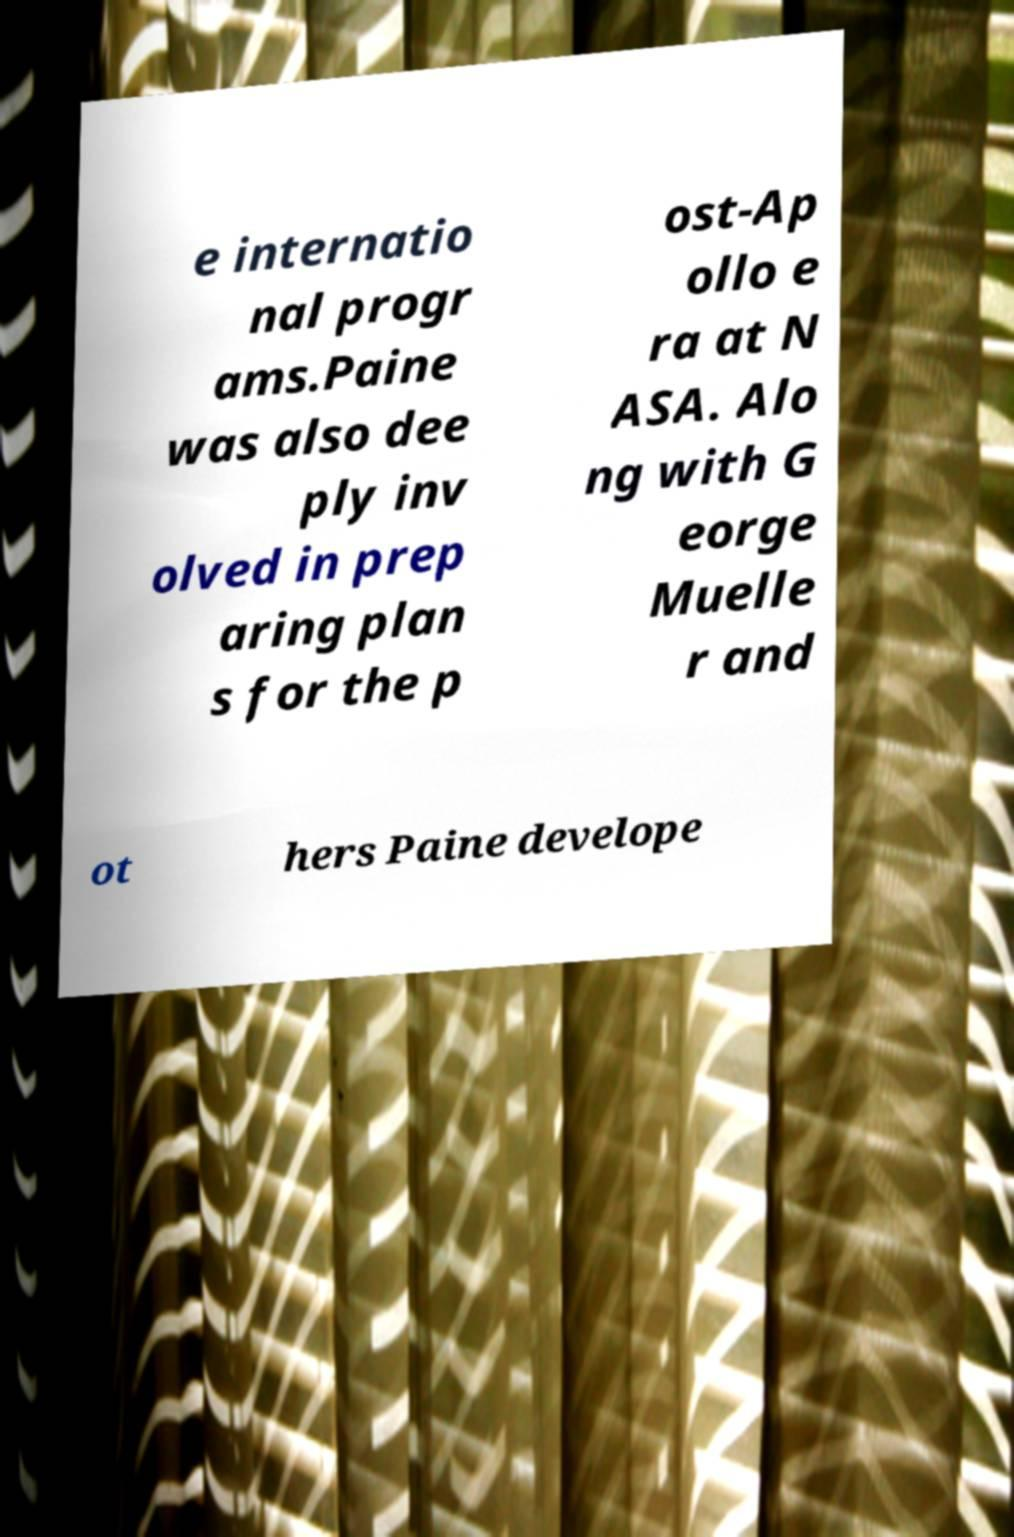Please read and relay the text visible in this image. What does it say? e internatio nal progr ams.Paine was also dee ply inv olved in prep aring plan s for the p ost-Ap ollo e ra at N ASA. Alo ng with G eorge Muelle r and ot hers Paine develope 